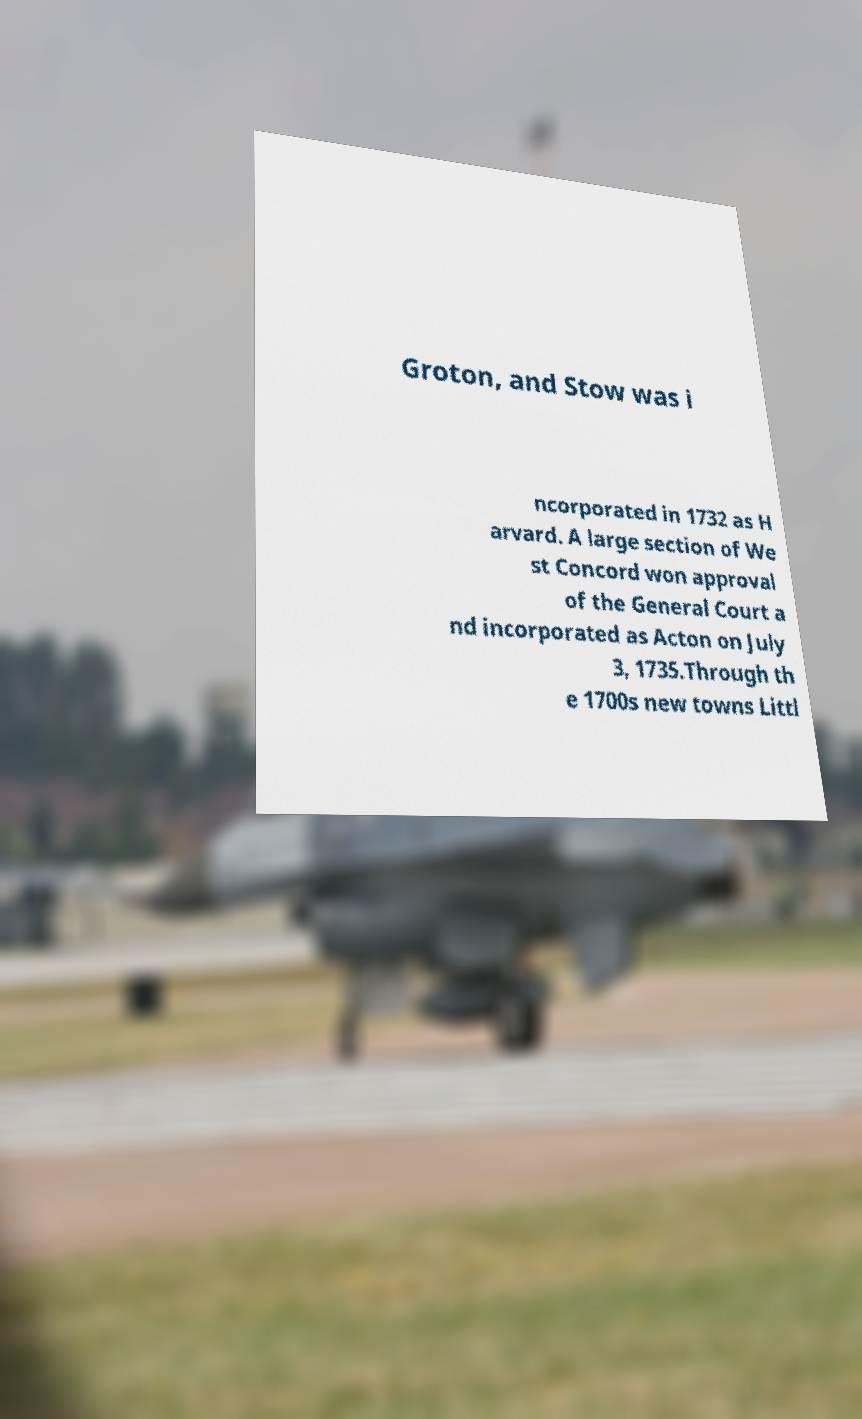Please read and relay the text visible in this image. What does it say? Groton, and Stow was i ncorporated in 1732 as H arvard. A large section of We st Concord won approval of the General Court a nd incorporated as Acton on July 3, 1735.Through th e 1700s new towns Littl 